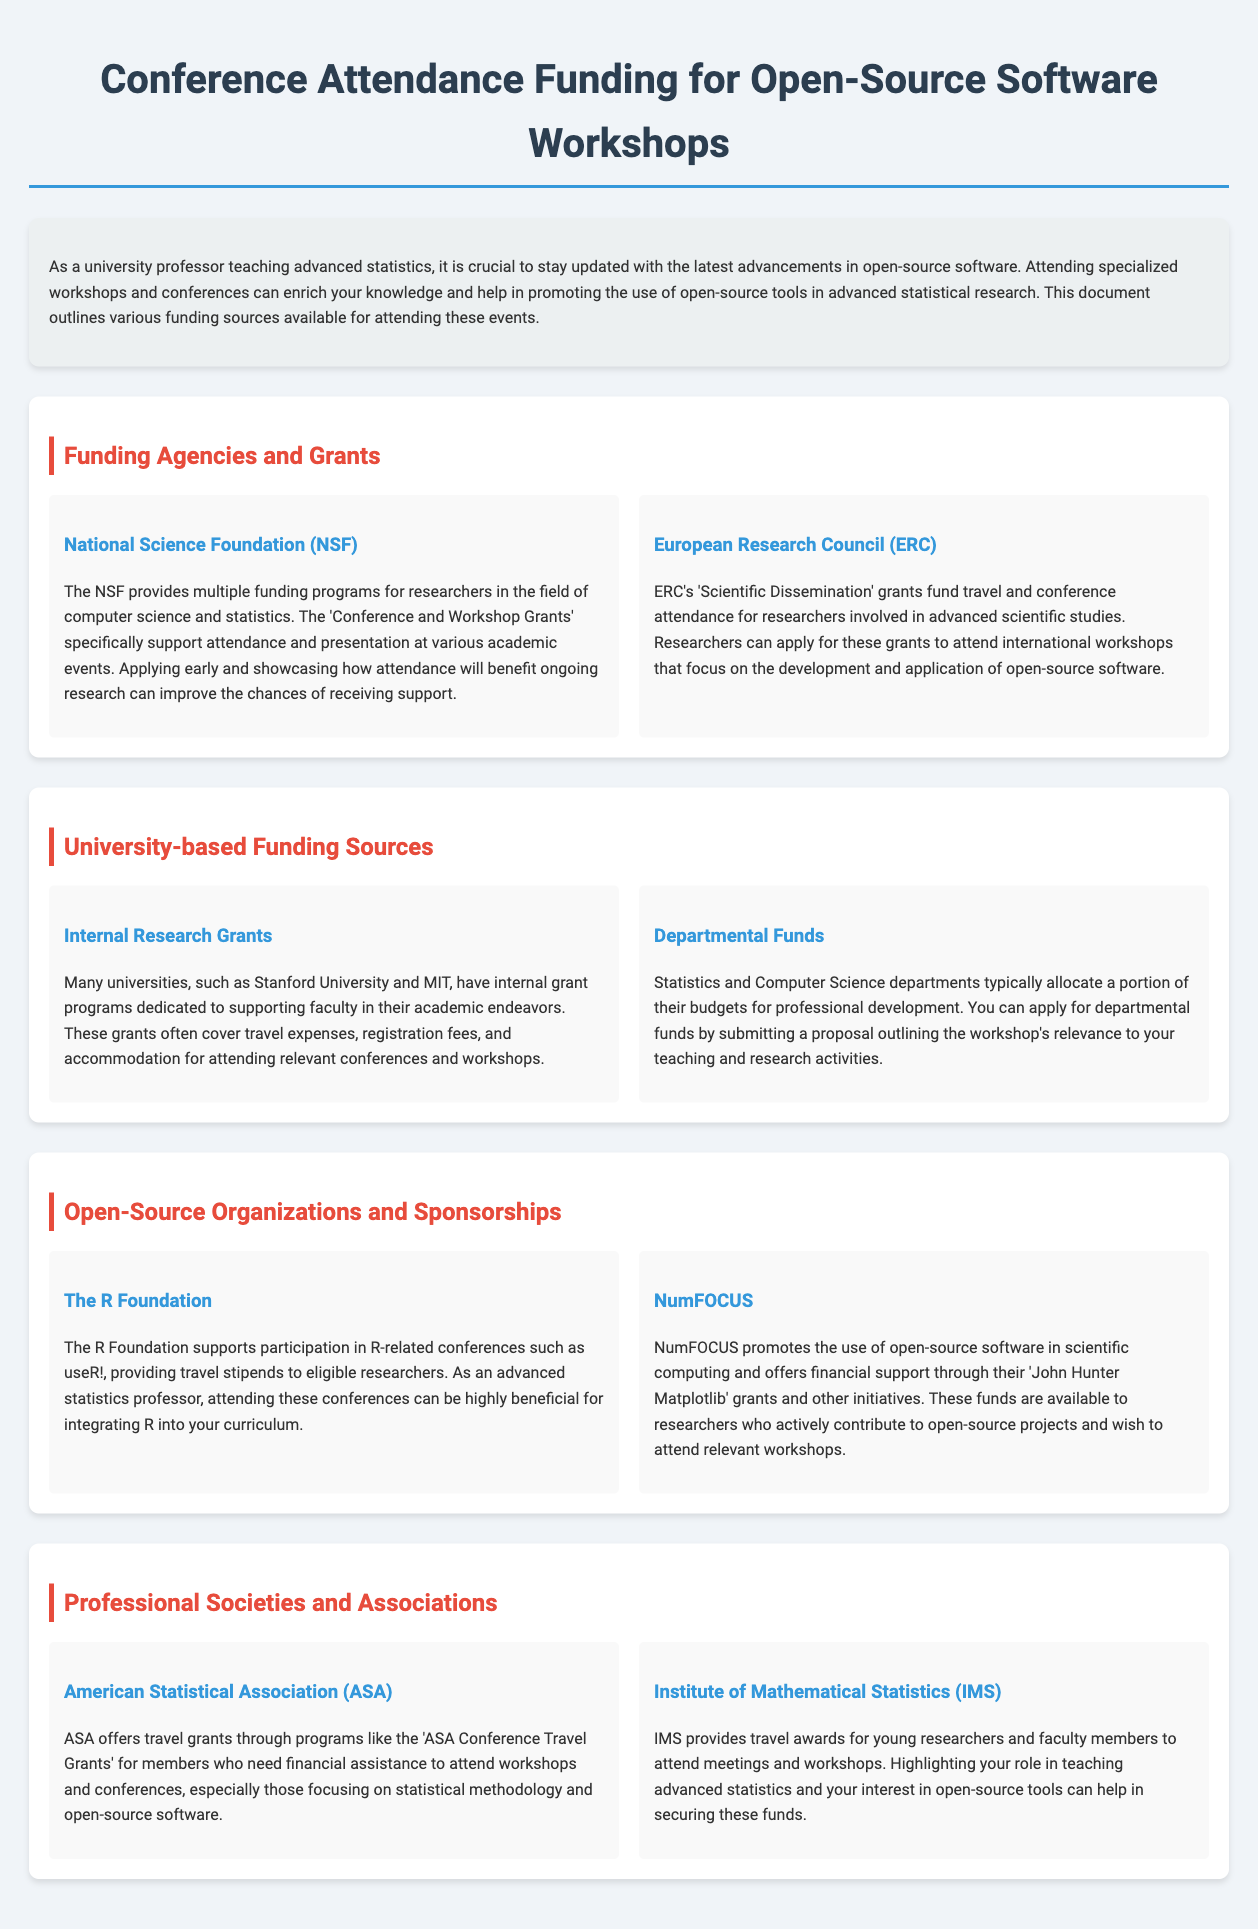What is the title of the document? The title is located at the top of the document and introduces the main topic of the content.
Answer: Conference Attendance Funding for Open-Source Software Workshops What funding program does the National Science Foundation provide? The document specifically mentions the NSF's program that supports attendance and presentation at academic events.
Answer: Conference and Workshop Grants Which organization provides travel stipends for R-related conferences? The document lists The R Foundation as supporting participation in R-related conferences.
Answer: The R Foundation What kind of grants does NumFOCUS offer? The document states that NumFOCUS promotes the use of open-source software and offers financial support through specific grants.
Answer: John Hunter Matplotlib grants Which professional society offers the ASA Conference Travel Grants? This funding opportunity is mentioned under the section discussing professional societies and their support for members.
Answer: American Statistical Association What is a requirement to apply for departmental funds? The document highlights the need to submit a proposal outlining relevant aspects of the workshop to get these funds.
Answer: Proposal outlining relevance What is the focus of the European Research Council's Scientific Dissemination grants? The document indicates that these grants are aimed at researchers in advanced scientific studies and their conference attendance.
Answer: Travel and conference attendance Who can receive travel awards from the Institute of Mathematical Statistics? This detail is provided in relation to who is eligible for the awards mentioned in the document.
Answer: Young researchers and faculty members 